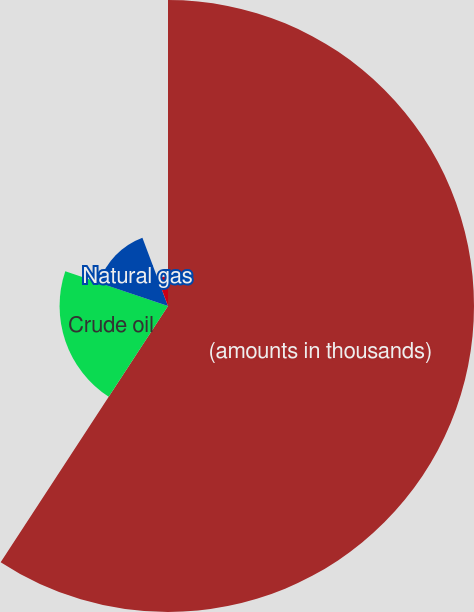Convert chart to OTSL. <chart><loc_0><loc_0><loc_500><loc_500><pie_chart><fcel>(amounts in thousands)<fcel>Crude oil<fcel>Natural gas<fcel>Refined products<nl><fcel>59.21%<fcel>20.98%<fcel>14.09%<fcel>5.72%<nl></chart> 